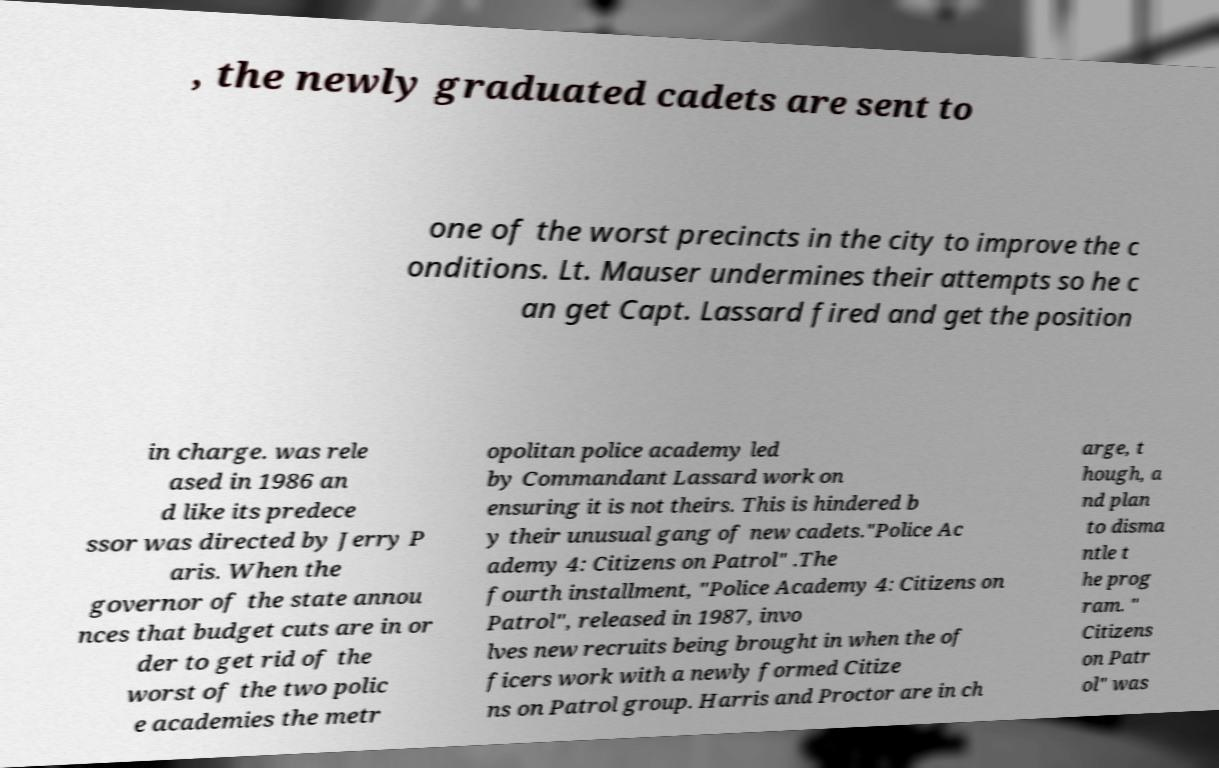Please read and relay the text visible in this image. What does it say? , the newly graduated cadets are sent to one of the worst precincts in the city to improve the c onditions. Lt. Mauser undermines their attempts so he c an get Capt. Lassard fired and get the position in charge. was rele ased in 1986 an d like its predece ssor was directed by Jerry P aris. When the governor of the state annou nces that budget cuts are in or der to get rid of the worst of the two polic e academies the metr opolitan police academy led by Commandant Lassard work on ensuring it is not theirs. This is hindered b y their unusual gang of new cadets."Police Ac ademy 4: Citizens on Patrol" .The fourth installment, "Police Academy 4: Citizens on Patrol", released in 1987, invo lves new recruits being brought in when the of ficers work with a newly formed Citize ns on Patrol group. Harris and Proctor are in ch arge, t hough, a nd plan to disma ntle t he prog ram. " Citizens on Patr ol" was 